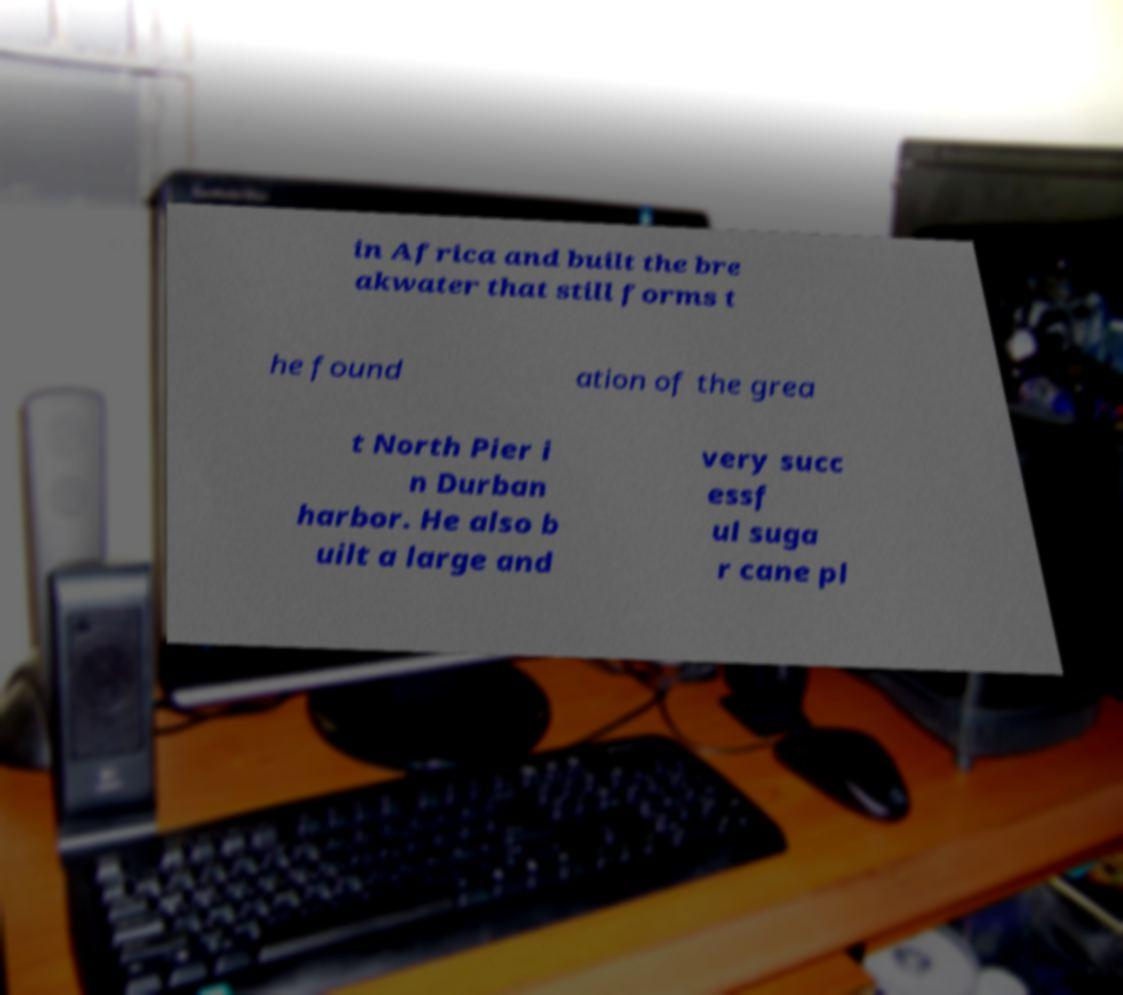There's text embedded in this image that I need extracted. Can you transcribe it verbatim? in Africa and built the bre akwater that still forms t he found ation of the grea t North Pier i n Durban harbor. He also b uilt a large and very succ essf ul suga r cane pl 